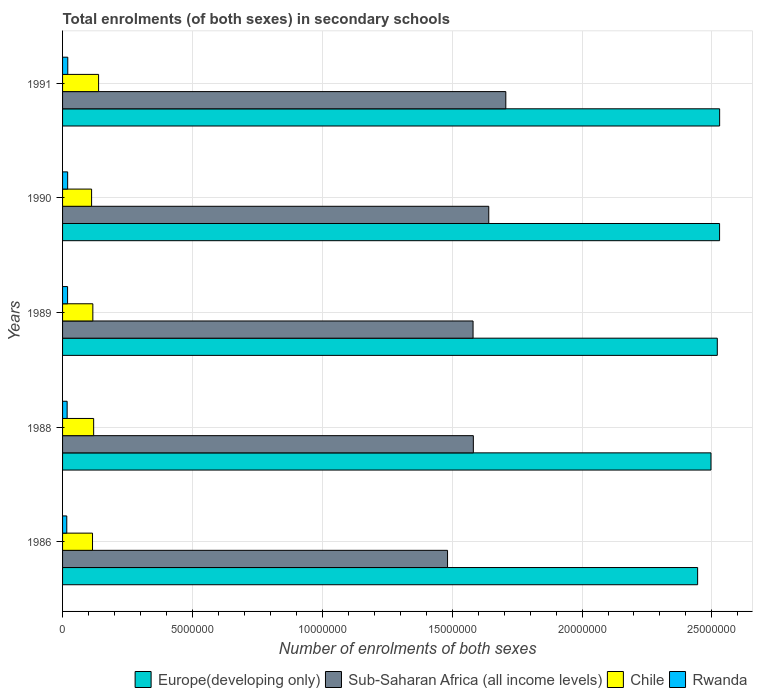Are the number of bars per tick equal to the number of legend labels?
Provide a succinct answer. Yes. Are the number of bars on each tick of the Y-axis equal?
Keep it short and to the point. Yes. In how many cases, is the number of bars for a given year not equal to the number of legend labels?
Offer a terse response. 0. What is the number of enrolments in secondary schools in Chile in 1988?
Provide a short and direct response. 1.20e+06. Across all years, what is the maximum number of enrolments in secondary schools in Europe(developing only)?
Provide a short and direct response. 2.53e+07. Across all years, what is the minimum number of enrolments in secondary schools in Rwanda?
Your answer should be very brief. 1.62e+05. In which year was the number of enrolments in secondary schools in Chile maximum?
Offer a very short reply. 1991. In which year was the number of enrolments in secondary schools in Sub-Saharan Africa (all income levels) minimum?
Keep it short and to the point. 1986. What is the total number of enrolments in secondary schools in Rwanda in the graph?
Your answer should be very brief. 9.28e+05. What is the difference between the number of enrolments in secondary schools in Sub-Saharan Africa (all income levels) in 1988 and that in 1991?
Offer a very short reply. -1.25e+06. What is the difference between the number of enrolments in secondary schools in Europe(developing only) in 1991 and the number of enrolments in secondary schools in Sub-Saharan Africa (all income levels) in 1989?
Make the answer very short. 9.49e+06. What is the average number of enrolments in secondary schools in Sub-Saharan Africa (all income levels) per year?
Give a very brief answer. 1.60e+07. In the year 1986, what is the difference between the number of enrolments in secondary schools in Chile and number of enrolments in secondary schools in Sub-Saharan Africa (all income levels)?
Offer a terse response. -1.37e+07. In how many years, is the number of enrolments in secondary schools in Chile greater than 5000000 ?
Your response must be concise. 0. What is the ratio of the number of enrolments in secondary schools in Europe(developing only) in 1986 to that in 1990?
Make the answer very short. 0.97. Is the difference between the number of enrolments in secondary schools in Chile in 1986 and 1990 greater than the difference between the number of enrolments in secondary schools in Sub-Saharan Africa (all income levels) in 1986 and 1990?
Make the answer very short. Yes. What is the difference between the highest and the second highest number of enrolments in secondary schools in Rwanda?
Your response must be concise. 4919. What is the difference between the highest and the lowest number of enrolments in secondary schools in Sub-Saharan Africa (all income levels)?
Make the answer very short. 2.24e+06. Is it the case that in every year, the sum of the number of enrolments in secondary schools in Chile and number of enrolments in secondary schools in Europe(developing only) is greater than the sum of number of enrolments in secondary schools in Sub-Saharan Africa (all income levels) and number of enrolments in secondary schools in Rwanda?
Your answer should be very brief. No. What does the 1st bar from the top in 1990 represents?
Your answer should be very brief. Rwanda. What does the 4th bar from the bottom in 1991 represents?
Provide a succinct answer. Rwanda. Is it the case that in every year, the sum of the number of enrolments in secondary schools in Rwanda and number of enrolments in secondary schools in Europe(developing only) is greater than the number of enrolments in secondary schools in Sub-Saharan Africa (all income levels)?
Offer a very short reply. Yes. How many bars are there?
Ensure brevity in your answer.  20. What is the difference between two consecutive major ticks on the X-axis?
Your answer should be very brief. 5.00e+06. Does the graph contain any zero values?
Offer a terse response. No. Does the graph contain grids?
Your answer should be compact. Yes. Where does the legend appear in the graph?
Keep it short and to the point. Bottom right. How many legend labels are there?
Provide a short and direct response. 4. How are the legend labels stacked?
Provide a succinct answer. Horizontal. What is the title of the graph?
Ensure brevity in your answer.  Total enrolments (of both sexes) in secondary schools. What is the label or title of the X-axis?
Your answer should be compact. Number of enrolments of both sexes. What is the label or title of the Y-axis?
Provide a short and direct response. Years. What is the Number of enrolments of both sexes in Europe(developing only) in 1986?
Keep it short and to the point. 2.45e+07. What is the Number of enrolments of both sexes of Sub-Saharan Africa (all income levels) in 1986?
Offer a very short reply. 1.48e+07. What is the Number of enrolments of both sexes of Chile in 1986?
Give a very brief answer. 1.15e+06. What is the Number of enrolments of both sexes of Rwanda in 1986?
Provide a succinct answer. 1.62e+05. What is the Number of enrolments of both sexes in Europe(developing only) in 1988?
Your answer should be very brief. 2.50e+07. What is the Number of enrolments of both sexes of Sub-Saharan Africa (all income levels) in 1988?
Provide a short and direct response. 1.58e+07. What is the Number of enrolments of both sexes in Chile in 1988?
Your answer should be compact. 1.20e+06. What is the Number of enrolments of both sexes in Rwanda in 1988?
Provide a short and direct response. 1.76e+05. What is the Number of enrolments of both sexes in Europe(developing only) in 1989?
Keep it short and to the point. 2.52e+07. What is the Number of enrolments of both sexes in Sub-Saharan Africa (all income levels) in 1989?
Make the answer very short. 1.58e+07. What is the Number of enrolments of both sexes of Chile in 1989?
Give a very brief answer. 1.17e+06. What is the Number of enrolments of both sexes of Rwanda in 1989?
Your answer should be compact. 1.93e+05. What is the Number of enrolments of both sexes in Europe(developing only) in 1990?
Offer a very short reply. 2.53e+07. What is the Number of enrolments of both sexes in Sub-Saharan Africa (all income levels) in 1990?
Give a very brief answer. 1.64e+07. What is the Number of enrolments of both sexes of Chile in 1990?
Give a very brief answer. 1.12e+06. What is the Number of enrolments of both sexes of Rwanda in 1990?
Provide a short and direct response. 1.96e+05. What is the Number of enrolments of both sexes in Europe(developing only) in 1991?
Make the answer very short. 2.53e+07. What is the Number of enrolments of both sexes in Sub-Saharan Africa (all income levels) in 1991?
Give a very brief answer. 1.71e+07. What is the Number of enrolments of both sexes in Chile in 1991?
Provide a short and direct response. 1.39e+06. What is the Number of enrolments of both sexes in Rwanda in 1991?
Ensure brevity in your answer.  2.01e+05. Across all years, what is the maximum Number of enrolments of both sexes in Europe(developing only)?
Your answer should be very brief. 2.53e+07. Across all years, what is the maximum Number of enrolments of both sexes of Sub-Saharan Africa (all income levels)?
Provide a short and direct response. 1.71e+07. Across all years, what is the maximum Number of enrolments of both sexes of Chile?
Provide a succinct answer. 1.39e+06. Across all years, what is the maximum Number of enrolments of both sexes in Rwanda?
Your answer should be compact. 2.01e+05. Across all years, what is the minimum Number of enrolments of both sexes in Europe(developing only)?
Offer a terse response. 2.45e+07. Across all years, what is the minimum Number of enrolments of both sexes of Sub-Saharan Africa (all income levels)?
Your answer should be very brief. 1.48e+07. Across all years, what is the minimum Number of enrolments of both sexes of Chile?
Give a very brief answer. 1.12e+06. Across all years, what is the minimum Number of enrolments of both sexes of Rwanda?
Give a very brief answer. 1.62e+05. What is the total Number of enrolments of both sexes of Europe(developing only) in the graph?
Your answer should be very brief. 1.25e+08. What is the total Number of enrolments of both sexes of Sub-Saharan Africa (all income levels) in the graph?
Offer a very short reply. 7.99e+07. What is the total Number of enrolments of both sexes of Chile in the graph?
Keep it short and to the point. 6.02e+06. What is the total Number of enrolments of both sexes of Rwanda in the graph?
Keep it short and to the point. 9.28e+05. What is the difference between the Number of enrolments of both sexes of Europe(developing only) in 1986 and that in 1988?
Make the answer very short. -5.14e+05. What is the difference between the Number of enrolments of both sexes in Sub-Saharan Africa (all income levels) in 1986 and that in 1988?
Ensure brevity in your answer.  -9.93e+05. What is the difference between the Number of enrolments of both sexes in Chile in 1986 and that in 1988?
Keep it short and to the point. -4.36e+04. What is the difference between the Number of enrolments of both sexes of Rwanda in 1986 and that in 1988?
Provide a succinct answer. -1.42e+04. What is the difference between the Number of enrolments of both sexes in Europe(developing only) in 1986 and that in 1989?
Ensure brevity in your answer.  -7.57e+05. What is the difference between the Number of enrolments of both sexes of Sub-Saharan Africa (all income levels) in 1986 and that in 1989?
Keep it short and to the point. -9.82e+05. What is the difference between the Number of enrolments of both sexes in Chile in 1986 and that in 1989?
Make the answer very short. -1.25e+04. What is the difference between the Number of enrolments of both sexes in Rwanda in 1986 and that in 1989?
Ensure brevity in your answer.  -3.11e+04. What is the difference between the Number of enrolments of both sexes of Europe(developing only) in 1986 and that in 1990?
Offer a very short reply. -8.45e+05. What is the difference between the Number of enrolments of both sexes of Sub-Saharan Africa (all income levels) in 1986 and that in 1990?
Give a very brief answer. -1.59e+06. What is the difference between the Number of enrolments of both sexes in Chile in 1986 and that in 1990?
Keep it short and to the point. 3.57e+04. What is the difference between the Number of enrolments of both sexes in Rwanda in 1986 and that in 1990?
Your answer should be very brief. -3.37e+04. What is the difference between the Number of enrolments of both sexes of Europe(developing only) in 1986 and that in 1991?
Provide a succinct answer. -8.47e+05. What is the difference between the Number of enrolments of both sexes of Sub-Saharan Africa (all income levels) in 1986 and that in 1991?
Your response must be concise. -2.24e+06. What is the difference between the Number of enrolments of both sexes of Chile in 1986 and that in 1991?
Make the answer very short. -2.34e+05. What is the difference between the Number of enrolments of both sexes of Rwanda in 1986 and that in 1991?
Offer a terse response. -3.86e+04. What is the difference between the Number of enrolments of both sexes of Europe(developing only) in 1988 and that in 1989?
Offer a very short reply. -2.43e+05. What is the difference between the Number of enrolments of both sexes of Sub-Saharan Africa (all income levels) in 1988 and that in 1989?
Keep it short and to the point. 1.07e+04. What is the difference between the Number of enrolments of both sexes in Chile in 1988 and that in 1989?
Provide a succinct answer. 3.11e+04. What is the difference between the Number of enrolments of both sexes in Rwanda in 1988 and that in 1989?
Offer a very short reply. -1.69e+04. What is the difference between the Number of enrolments of both sexes of Europe(developing only) in 1988 and that in 1990?
Offer a very short reply. -3.31e+05. What is the difference between the Number of enrolments of both sexes in Sub-Saharan Africa (all income levels) in 1988 and that in 1990?
Make the answer very short. -5.94e+05. What is the difference between the Number of enrolments of both sexes of Chile in 1988 and that in 1990?
Your answer should be compact. 7.93e+04. What is the difference between the Number of enrolments of both sexes in Rwanda in 1988 and that in 1990?
Your answer should be compact. -1.95e+04. What is the difference between the Number of enrolments of both sexes in Europe(developing only) in 1988 and that in 1991?
Your answer should be very brief. -3.33e+05. What is the difference between the Number of enrolments of both sexes in Sub-Saharan Africa (all income levels) in 1988 and that in 1991?
Provide a short and direct response. -1.25e+06. What is the difference between the Number of enrolments of both sexes in Chile in 1988 and that in 1991?
Offer a terse response. -1.90e+05. What is the difference between the Number of enrolments of both sexes of Rwanda in 1988 and that in 1991?
Make the answer very short. -2.44e+04. What is the difference between the Number of enrolments of both sexes of Europe(developing only) in 1989 and that in 1990?
Your response must be concise. -8.77e+04. What is the difference between the Number of enrolments of both sexes in Sub-Saharan Africa (all income levels) in 1989 and that in 1990?
Provide a short and direct response. -6.05e+05. What is the difference between the Number of enrolments of both sexes in Chile in 1989 and that in 1990?
Give a very brief answer. 4.82e+04. What is the difference between the Number of enrolments of both sexes of Rwanda in 1989 and that in 1990?
Your response must be concise. -2555. What is the difference between the Number of enrolments of both sexes in Europe(developing only) in 1989 and that in 1991?
Give a very brief answer. -8.99e+04. What is the difference between the Number of enrolments of both sexes of Sub-Saharan Africa (all income levels) in 1989 and that in 1991?
Provide a short and direct response. -1.26e+06. What is the difference between the Number of enrolments of both sexes in Chile in 1989 and that in 1991?
Make the answer very short. -2.21e+05. What is the difference between the Number of enrolments of both sexes of Rwanda in 1989 and that in 1991?
Your answer should be very brief. -7474. What is the difference between the Number of enrolments of both sexes in Europe(developing only) in 1990 and that in 1991?
Offer a very short reply. -2206. What is the difference between the Number of enrolments of both sexes in Sub-Saharan Africa (all income levels) in 1990 and that in 1991?
Your response must be concise. -6.57e+05. What is the difference between the Number of enrolments of both sexes of Chile in 1990 and that in 1991?
Provide a short and direct response. -2.69e+05. What is the difference between the Number of enrolments of both sexes of Rwanda in 1990 and that in 1991?
Your response must be concise. -4919. What is the difference between the Number of enrolments of both sexes in Europe(developing only) in 1986 and the Number of enrolments of both sexes in Sub-Saharan Africa (all income levels) in 1988?
Your answer should be very brief. 8.64e+06. What is the difference between the Number of enrolments of both sexes in Europe(developing only) in 1986 and the Number of enrolments of both sexes in Chile in 1988?
Offer a very short reply. 2.33e+07. What is the difference between the Number of enrolments of both sexes of Europe(developing only) in 1986 and the Number of enrolments of both sexes of Rwanda in 1988?
Provide a short and direct response. 2.43e+07. What is the difference between the Number of enrolments of both sexes in Sub-Saharan Africa (all income levels) in 1986 and the Number of enrolments of both sexes in Chile in 1988?
Your response must be concise. 1.36e+07. What is the difference between the Number of enrolments of both sexes in Sub-Saharan Africa (all income levels) in 1986 and the Number of enrolments of both sexes in Rwanda in 1988?
Give a very brief answer. 1.46e+07. What is the difference between the Number of enrolments of both sexes in Chile in 1986 and the Number of enrolments of both sexes in Rwanda in 1988?
Provide a short and direct response. 9.77e+05. What is the difference between the Number of enrolments of both sexes in Europe(developing only) in 1986 and the Number of enrolments of both sexes in Sub-Saharan Africa (all income levels) in 1989?
Your answer should be very brief. 8.65e+06. What is the difference between the Number of enrolments of both sexes of Europe(developing only) in 1986 and the Number of enrolments of both sexes of Chile in 1989?
Your answer should be compact. 2.33e+07. What is the difference between the Number of enrolments of both sexes in Europe(developing only) in 1986 and the Number of enrolments of both sexes in Rwanda in 1989?
Ensure brevity in your answer.  2.43e+07. What is the difference between the Number of enrolments of both sexes of Sub-Saharan Africa (all income levels) in 1986 and the Number of enrolments of both sexes of Chile in 1989?
Provide a short and direct response. 1.37e+07. What is the difference between the Number of enrolments of both sexes of Sub-Saharan Africa (all income levels) in 1986 and the Number of enrolments of both sexes of Rwanda in 1989?
Offer a very short reply. 1.46e+07. What is the difference between the Number of enrolments of both sexes in Chile in 1986 and the Number of enrolments of both sexes in Rwanda in 1989?
Your response must be concise. 9.60e+05. What is the difference between the Number of enrolments of both sexes of Europe(developing only) in 1986 and the Number of enrolments of both sexes of Sub-Saharan Africa (all income levels) in 1990?
Your answer should be compact. 8.04e+06. What is the difference between the Number of enrolments of both sexes of Europe(developing only) in 1986 and the Number of enrolments of both sexes of Chile in 1990?
Make the answer very short. 2.33e+07. What is the difference between the Number of enrolments of both sexes of Europe(developing only) in 1986 and the Number of enrolments of both sexes of Rwanda in 1990?
Offer a very short reply. 2.43e+07. What is the difference between the Number of enrolments of both sexes of Sub-Saharan Africa (all income levels) in 1986 and the Number of enrolments of both sexes of Chile in 1990?
Ensure brevity in your answer.  1.37e+07. What is the difference between the Number of enrolments of both sexes of Sub-Saharan Africa (all income levels) in 1986 and the Number of enrolments of both sexes of Rwanda in 1990?
Your answer should be compact. 1.46e+07. What is the difference between the Number of enrolments of both sexes of Chile in 1986 and the Number of enrolments of both sexes of Rwanda in 1990?
Give a very brief answer. 9.58e+05. What is the difference between the Number of enrolments of both sexes in Europe(developing only) in 1986 and the Number of enrolments of both sexes in Sub-Saharan Africa (all income levels) in 1991?
Make the answer very short. 7.38e+06. What is the difference between the Number of enrolments of both sexes of Europe(developing only) in 1986 and the Number of enrolments of both sexes of Chile in 1991?
Provide a short and direct response. 2.31e+07. What is the difference between the Number of enrolments of both sexes of Europe(developing only) in 1986 and the Number of enrolments of both sexes of Rwanda in 1991?
Ensure brevity in your answer.  2.43e+07. What is the difference between the Number of enrolments of both sexes in Sub-Saharan Africa (all income levels) in 1986 and the Number of enrolments of both sexes in Chile in 1991?
Make the answer very short. 1.34e+07. What is the difference between the Number of enrolments of both sexes in Sub-Saharan Africa (all income levels) in 1986 and the Number of enrolments of both sexes in Rwanda in 1991?
Make the answer very short. 1.46e+07. What is the difference between the Number of enrolments of both sexes of Chile in 1986 and the Number of enrolments of both sexes of Rwanda in 1991?
Provide a succinct answer. 9.53e+05. What is the difference between the Number of enrolments of both sexes in Europe(developing only) in 1988 and the Number of enrolments of both sexes in Sub-Saharan Africa (all income levels) in 1989?
Your answer should be very brief. 9.16e+06. What is the difference between the Number of enrolments of both sexes in Europe(developing only) in 1988 and the Number of enrolments of both sexes in Chile in 1989?
Your answer should be very brief. 2.38e+07. What is the difference between the Number of enrolments of both sexes of Europe(developing only) in 1988 and the Number of enrolments of both sexes of Rwanda in 1989?
Offer a terse response. 2.48e+07. What is the difference between the Number of enrolments of both sexes in Sub-Saharan Africa (all income levels) in 1988 and the Number of enrolments of both sexes in Chile in 1989?
Offer a terse response. 1.46e+07. What is the difference between the Number of enrolments of both sexes in Sub-Saharan Africa (all income levels) in 1988 and the Number of enrolments of both sexes in Rwanda in 1989?
Provide a short and direct response. 1.56e+07. What is the difference between the Number of enrolments of both sexes in Chile in 1988 and the Number of enrolments of both sexes in Rwanda in 1989?
Keep it short and to the point. 1.00e+06. What is the difference between the Number of enrolments of both sexes of Europe(developing only) in 1988 and the Number of enrolments of both sexes of Sub-Saharan Africa (all income levels) in 1990?
Give a very brief answer. 8.56e+06. What is the difference between the Number of enrolments of both sexes in Europe(developing only) in 1988 and the Number of enrolments of both sexes in Chile in 1990?
Your answer should be compact. 2.38e+07. What is the difference between the Number of enrolments of both sexes of Europe(developing only) in 1988 and the Number of enrolments of both sexes of Rwanda in 1990?
Your answer should be very brief. 2.48e+07. What is the difference between the Number of enrolments of both sexes in Sub-Saharan Africa (all income levels) in 1988 and the Number of enrolments of both sexes in Chile in 1990?
Give a very brief answer. 1.47e+07. What is the difference between the Number of enrolments of both sexes of Sub-Saharan Africa (all income levels) in 1988 and the Number of enrolments of both sexes of Rwanda in 1990?
Keep it short and to the point. 1.56e+07. What is the difference between the Number of enrolments of both sexes of Chile in 1988 and the Number of enrolments of both sexes of Rwanda in 1990?
Offer a terse response. 1.00e+06. What is the difference between the Number of enrolments of both sexes of Europe(developing only) in 1988 and the Number of enrolments of both sexes of Sub-Saharan Africa (all income levels) in 1991?
Your answer should be very brief. 7.90e+06. What is the difference between the Number of enrolments of both sexes of Europe(developing only) in 1988 and the Number of enrolments of both sexes of Chile in 1991?
Your answer should be very brief. 2.36e+07. What is the difference between the Number of enrolments of both sexes in Europe(developing only) in 1988 and the Number of enrolments of both sexes in Rwanda in 1991?
Provide a succinct answer. 2.48e+07. What is the difference between the Number of enrolments of both sexes of Sub-Saharan Africa (all income levels) in 1988 and the Number of enrolments of both sexes of Chile in 1991?
Provide a succinct answer. 1.44e+07. What is the difference between the Number of enrolments of both sexes of Sub-Saharan Africa (all income levels) in 1988 and the Number of enrolments of both sexes of Rwanda in 1991?
Keep it short and to the point. 1.56e+07. What is the difference between the Number of enrolments of both sexes in Chile in 1988 and the Number of enrolments of both sexes in Rwanda in 1991?
Your answer should be very brief. 9.96e+05. What is the difference between the Number of enrolments of both sexes in Europe(developing only) in 1989 and the Number of enrolments of both sexes in Sub-Saharan Africa (all income levels) in 1990?
Ensure brevity in your answer.  8.80e+06. What is the difference between the Number of enrolments of both sexes in Europe(developing only) in 1989 and the Number of enrolments of both sexes in Chile in 1990?
Offer a very short reply. 2.41e+07. What is the difference between the Number of enrolments of both sexes in Europe(developing only) in 1989 and the Number of enrolments of both sexes in Rwanda in 1990?
Give a very brief answer. 2.50e+07. What is the difference between the Number of enrolments of both sexes in Sub-Saharan Africa (all income levels) in 1989 and the Number of enrolments of both sexes in Chile in 1990?
Make the answer very short. 1.47e+07. What is the difference between the Number of enrolments of both sexes in Sub-Saharan Africa (all income levels) in 1989 and the Number of enrolments of both sexes in Rwanda in 1990?
Your answer should be very brief. 1.56e+07. What is the difference between the Number of enrolments of both sexes in Chile in 1989 and the Number of enrolments of both sexes in Rwanda in 1990?
Offer a terse response. 9.70e+05. What is the difference between the Number of enrolments of both sexes in Europe(developing only) in 1989 and the Number of enrolments of both sexes in Sub-Saharan Africa (all income levels) in 1991?
Your answer should be very brief. 8.14e+06. What is the difference between the Number of enrolments of both sexes of Europe(developing only) in 1989 and the Number of enrolments of both sexes of Chile in 1991?
Provide a short and direct response. 2.38e+07. What is the difference between the Number of enrolments of both sexes in Europe(developing only) in 1989 and the Number of enrolments of both sexes in Rwanda in 1991?
Ensure brevity in your answer.  2.50e+07. What is the difference between the Number of enrolments of both sexes of Sub-Saharan Africa (all income levels) in 1989 and the Number of enrolments of both sexes of Chile in 1991?
Your answer should be very brief. 1.44e+07. What is the difference between the Number of enrolments of both sexes of Sub-Saharan Africa (all income levels) in 1989 and the Number of enrolments of both sexes of Rwanda in 1991?
Ensure brevity in your answer.  1.56e+07. What is the difference between the Number of enrolments of both sexes in Chile in 1989 and the Number of enrolments of both sexes in Rwanda in 1991?
Keep it short and to the point. 9.65e+05. What is the difference between the Number of enrolments of both sexes in Europe(developing only) in 1990 and the Number of enrolments of both sexes in Sub-Saharan Africa (all income levels) in 1991?
Make the answer very short. 8.23e+06. What is the difference between the Number of enrolments of both sexes in Europe(developing only) in 1990 and the Number of enrolments of both sexes in Chile in 1991?
Keep it short and to the point. 2.39e+07. What is the difference between the Number of enrolments of both sexes in Europe(developing only) in 1990 and the Number of enrolments of both sexes in Rwanda in 1991?
Ensure brevity in your answer.  2.51e+07. What is the difference between the Number of enrolments of both sexes of Sub-Saharan Africa (all income levels) in 1990 and the Number of enrolments of both sexes of Chile in 1991?
Your answer should be very brief. 1.50e+07. What is the difference between the Number of enrolments of both sexes of Sub-Saharan Africa (all income levels) in 1990 and the Number of enrolments of both sexes of Rwanda in 1991?
Give a very brief answer. 1.62e+07. What is the difference between the Number of enrolments of both sexes in Chile in 1990 and the Number of enrolments of both sexes in Rwanda in 1991?
Ensure brevity in your answer.  9.17e+05. What is the average Number of enrolments of both sexes of Europe(developing only) per year?
Provide a succinct answer. 2.50e+07. What is the average Number of enrolments of both sexes of Sub-Saharan Africa (all income levels) per year?
Give a very brief answer. 1.60e+07. What is the average Number of enrolments of both sexes of Chile per year?
Offer a terse response. 1.20e+06. What is the average Number of enrolments of both sexes of Rwanda per year?
Keep it short and to the point. 1.86e+05. In the year 1986, what is the difference between the Number of enrolments of both sexes of Europe(developing only) and Number of enrolments of both sexes of Sub-Saharan Africa (all income levels)?
Provide a short and direct response. 9.63e+06. In the year 1986, what is the difference between the Number of enrolments of both sexes in Europe(developing only) and Number of enrolments of both sexes in Chile?
Provide a short and direct response. 2.33e+07. In the year 1986, what is the difference between the Number of enrolments of both sexes of Europe(developing only) and Number of enrolments of both sexes of Rwanda?
Your response must be concise. 2.43e+07. In the year 1986, what is the difference between the Number of enrolments of both sexes in Sub-Saharan Africa (all income levels) and Number of enrolments of both sexes in Chile?
Keep it short and to the point. 1.37e+07. In the year 1986, what is the difference between the Number of enrolments of both sexes in Sub-Saharan Africa (all income levels) and Number of enrolments of both sexes in Rwanda?
Keep it short and to the point. 1.47e+07. In the year 1986, what is the difference between the Number of enrolments of both sexes in Chile and Number of enrolments of both sexes in Rwanda?
Give a very brief answer. 9.91e+05. In the year 1988, what is the difference between the Number of enrolments of both sexes of Europe(developing only) and Number of enrolments of both sexes of Sub-Saharan Africa (all income levels)?
Ensure brevity in your answer.  9.15e+06. In the year 1988, what is the difference between the Number of enrolments of both sexes of Europe(developing only) and Number of enrolments of both sexes of Chile?
Give a very brief answer. 2.38e+07. In the year 1988, what is the difference between the Number of enrolments of both sexes in Europe(developing only) and Number of enrolments of both sexes in Rwanda?
Offer a very short reply. 2.48e+07. In the year 1988, what is the difference between the Number of enrolments of both sexes in Sub-Saharan Africa (all income levels) and Number of enrolments of both sexes in Chile?
Give a very brief answer. 1.46e+07. In the year 1988, what is the difference between the Number of enrolments of both sexes of Sub-Saharan Africa (all income levels) and Number of enrolments of both sexes of Rwanda?
Ensure brevity in your answer.  1.56e+07. In the year 1988, what is the difference between the Number of enrolments of both sexes of Chile and Number of enrolments of both sexes of Rwanda?
Provide a succinct answer. 1.02e+06. In the year 1989, what is the difference between the Number of enrolments of both sexes in Europe(developing only) and Number of enrolments of both sexes in Sub-Saharan Africa (all income levels)?
Offer a very short reply. 9.40e+06. In the year 1989, what is the difference between the Number of enrolments of both sexes in Europe(developing only) and Number of enrolments of both sexes in Chile?
Your answer should be compact. 2.40e+07. In the year 1989, what is the difference between the Number of enrolments of both sexes in Europe(developing only) and Number of enrolments of both sexes in Rwanda?
Your response must be concise. 2.50e+07. In the year 1989, what is the difference between the Number of enrolments of both sexes in Sub-Saharan Africa (all income levels) and Number of enrolments of both sexes in Chile?
Your answer should be compact. 1.46e+07. In the year 1989, what is the difference between the Number of enrolments of both sexes of Sub-Saharan Africa (all income levels) and Number of enrolments of both sexes of Rwanda?
Keep it short and to the point. 1.56e+07. In the year 1989, what is the difference between the Number of enrolments of both sexes in Chile and Number of enrolments of both sexes in Rwanda?
Ensure brevity in your answer.  9.73e+05. In the year 1990, what is the difference between the Number of enrolments of both sexes in Europe(developing only) and Number of enrolments of both sexes in Sub-Saharan Africa (all income levels)?
Your answer should be very brief. 8.89e+06. In the year 1990, what is the difference between the Number of enrolments of both sexes of Europe(developing only) and Number of enrolments of both sexes of Chile?
Your response must be concise. 2.42e+07. In the year 1990, what is the difference between the Number of enrolments of both sexes in Europe(developing only) and Number of enrolments of both sexes in Rwanda?
Your answer should be compact. 2.51e+07. In the year 1990, what is the difference between the Number of enrolments of both sexes of Sub-Saharan Africa (all income levels) and Number of enrolments of both sexes of Chile?
Offer a very short reply. 1.53e+07. In the year 1990, what is the difference between the Number of enrolments of both sexes of Sub-Saharan Africa (all income levels) and Number of enrolments of both sexes of Rwanda?
Offer a very short reply. 1.62e+07. In the year 1990, what is the difference between the Number of enrolments of both sexes in Chile and Number of enrolments of both sexes in Rwanda?
Your response must be concise. 9.22e+05. In the year 1991, what is the difference between the Number of enrolments of both sexes in Europe(developing only) and Number of enrolments of both sexes in Sub-Saharan Africa (all income levels)?
Your answer should be very brief. 8.23e+06. In the year 1991, what is the difference between the Number of enrolments of both sexes of Europe(developing only) and Number of enrolments of both sexes of Chile?
Ensure brevity in your answer.  2.39e+07. In the year 1991, what is the difference between the Number of enrolments of both sexes in Europe(developing only) and Number of enrolments of both sexes in Rwanda?
Your answer should be very brief. 2.51e+07. In the year 1991, what is the difference between the Number of enrolments of both sexes in Sub-Saharan Africa (all income levels) and Number of enrolments of both sexes in Chile?
Offer a very short reply. 1.57e+07. In the year 1991, what is the difference between the Number of enrolments of both sexes of Sub-Saharan Africa (all income levels) and Number of enrolments of both sexes of Rwanda?
Your answer should be compact. 1.69e+07. In the year 1991, what is the difference between the Number of enrolments of both sexes of Chile and Number of enrolments of both sexes of Rwanda?
Your answer should be compact. 1.19e+06. What is the ratio of the Number of enrolments of both sexes of Europe(developing only) in 1986 to that in 1988?
Make the answer very short. 0.98. What is the ratio of the Number of enrolments of both sexes of Sub-Saharan Africa (all income levels) in 1986 to that in 1988?
Your response must be concise. 0.94. What is the ratio of the Number of enrolments of both sexes of Chile in 1986 to that in 1988?
Keep it short and to the point. 0.96. What is the ratio of the Number of enrolments of both sexes of Rwanda in 1986 to that in 1988?
Give a very brief answer. 0.92. What is the ratio of the Number of enrolments of both sexes of Europe(developing only) in 1986 to that in 1989?
Make the answer very short. 0.97. What is the ratio of the Number of enrolments of both sexes of Sub-Saharan Africa (all income levels) in 1986 to that in 1989?
Your answer should be compact. 0.94. What is the ratio of the Number of enrolments of both sexes in Chile in 1986 to that in 1989?
Keep it short and to the point. 0.99. What is the ratio of the Number of enrolments of both sexes in Rwanda in 1986 to that in 1989?
Ensure brevity in your answer.  0.84. What is the ratio of the Number of enrolments of both sexes in Europe(developing only) in 1986 to that in 1990?
Ensure brevity in your answer.  0.97. What is the ratio of the Number of enrolments of both sexes in Sub-Saharan Africa (all income levels) in 1986 to that in 1990?
Your answer should be very brief. 0.9. What is the ratio of the Number of enrolments of both sexes in Chile in 1986 to that in 1990?
Give a very brief answer. 1.03. What is the ratio of the Number of enrolments of both sexes in Rwanda in 1986 to that in 1990?
Your response must be concise. 0.83. What is the ratio of the Number of enrolments of both sexes of Europe(developing only) in 1986 to that in 1991?
Your answer should be compact. 0.97. What is the ratio of the Number of enrolments of both sexes of Sub-Saharan Africa (all income levels) in 1986 to that in 1991?
Your answer should be very brief. 0.87. What is the ratio of the Number of enrolments of both sexes in Chile in 1986 to that in 1991?
Make the answer very short. 0.83. What is the ratio of the Number of enrolments of both sexes of Rwanda in 1986 to that in 1991?
Offer a terse response. 0.81. What is the ratio of the Number of enrolments of both sexes in Europe(developing only) in 1988 to that in 1989?
Keep it short and to the point. 0.99. What is the ratio of the Number of enrolments of both sexes of Chile in 1988 to that in 1989?
Offer a very short reply. 1.03. What is the ratio of the Number of enrolments of both sexes in Rwanda in 1988 to that in 1989?
Give a very brief answer. 0.91. What is the ratio of the Number of enrolments of both sexes of Europe(developing only) in 1988 to that in 1990?
Offer a very short reply. 0.99. What is the ratio of the Number of enrolments of both sexes in Sub-Saharan Africa (all income levels) in 1988 to that in 1990?
Give a very brief answer. 0.96. What is the ratio of the Number of enrolments of both sexes of Chile in 1988 to that in 1990?
Offer a terse response. 1.07. What is the ratio of the Number of enrolments of both sexes of Rwanda in 1988 to that in 1990?
Offer a terse response. 0.9. What is the ratio of the Number of enrolments of both sexes in Europe(developing only) in 1988 to that in 1991?
Give a very brief answer. 0.99. What is the ratio of the Number of enrolments of both sexes in Sub-Saharan Africa (all income levels) in 1988 to that in 1991?
Offer a terse response. 0.93. What is the ratio of the Number of enrolments of both sexes in Chile in 1988 to that in 1991?
Ensure brevity in your answer.  0.86. What is the ratio of the Number of enrolments of both sexes of Rwanda in 1988 to that in 1991?
Offer a very short reply. 0.88. What is the ratio of the Number of enrolments of both sexes in Sub-Saharan Africa (all income levels) in 1989 to that in 1990?
Keep it short and to the point. 0.96. What is the ratio of the Number of enrolments of both sexes in Chile in 1989 to that in 1990?
Make the answer very short. 1.04. What is the ratio of the Number of enrolments of both sexes in Rwanda in 1989 to that in 1990?
Offer a very short reply. 0.99. What is the ratio of the Number of enrolments of both sexes of Sub-Saharan Africa (all income levels) in 1989 to that in 1991?
Your answer should be compact. 0.93. What is the ratio of the Number of enrolments of both sexes of Chile in 1989 to that in 1991?
Ensure brevity in your answer.  0.84. What is the ratio of the Number of enrolments of both sexes of Rwanda in 1989 to that in 1991?
Offer a very short reply. 0.96. What is the ratio of the Number of enrolments of both sexes in Sub-Saharan Africa (all income levels) in 1990 to that in 1991?
Offer a very short reply. 0.96. What is the ratio of the Number of enrolments of both sexes of Chile in 1990 to that in 1991?
Your answer should be very brief. 0.81. What is the ratio of the Number of enrolments of both sexes in Rwanda in 1990 to that in 1991?
Ensure brevity in your answer.  0.98. What is the difference between the highest and the second highest Number of enrolments of both sexes in Europe(developing only)?
Give a very brief answer. 2206. What is the difference between the highest and the second highest Number of enrolments of both sexes in Sub-Saharan Africa (all income levels)?
Your response must be concise. 6.57e+05. What is the difference between the highest and the second highest Number of enrolments of both sexes of Chile?
Give a very brief answer. 1.90e+05. What is the difference between the highest and the second highest Number of enrolments of both sexes of Rwanda?
Your answer should be very brief. 4919. What is the difference between the highest and the lowest Number of enrolments of both sexes of Europe(developing only)?
Your answer should be compact. 8.47e+05. What is the difference between the highest and the lowest Number of enrolments of both sexes in Sub-Saharan Africa (all income levels)?
Provide a succinct answer. 2.24e+06. What is the difference between the highest and the lowest Number of enrolments of both sexes in Chile?
Provide a short and direct response. 2.69e+05. What is the difference between the highest and the lowest Number of enrolments of both sexes in Rwanda?
Offer a very short reply. 3.86e+04. 